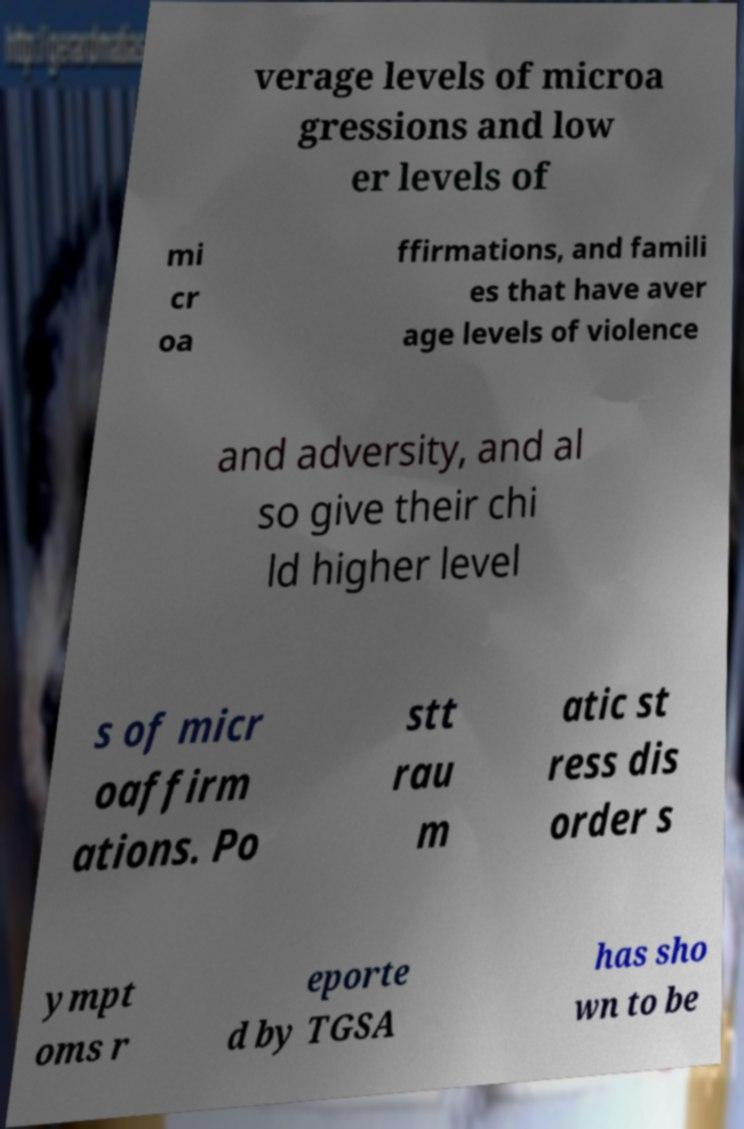I need the written content from this picture converted into text. Can you do that? verage levels of microa gressions and low er levels of mi cr oa ffirmations, and famili es that have aver age levels of violence and adversity, and al so give their chi ld higher level s of micr oaffirm ations. Po stt rau m atic st ress dis order s ympt oms r eporte d by TGSA has sho wn to be 